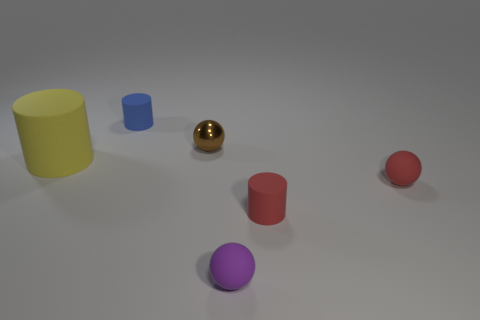Is there anything else that is the same material as the brown object?
Your response must be concise. No. What is the color of the metallic sphere that is the same size as the red cylinder?
Offer a terse response. Brown. Are there the same number of large yellow cylinders that are right of the large yellow object and large purple metal balls?
Make the answer very short. Yes. There is a tiny thing that is both behind the large yellow rubber cylinder and right of the tiny blue cylinder; what is its shape?
Your response must be concise. Sphere. Is the size of the yellow matte thing the same as the purple matte thing?
Give a very brief answer. No. Is there a ball made of the same material as the blue cylinder?
Offer a very short reply. Yes. What number of things are in front of the small shiny sphere and on the right side of the tiny blue rubber cylinder?
Provide a succinct answer. 3. There is a tiny cylinder that is in front of the small blue thing; what is its material?
Your answer should be compact. Rubber. What number of other tiny spheres have the same color as the small metallic ball?
Give a very brief answer. 0. There is a red ball that is the same material as the large thing; what is its size?
Ensure brevity in your answer.  Small. 